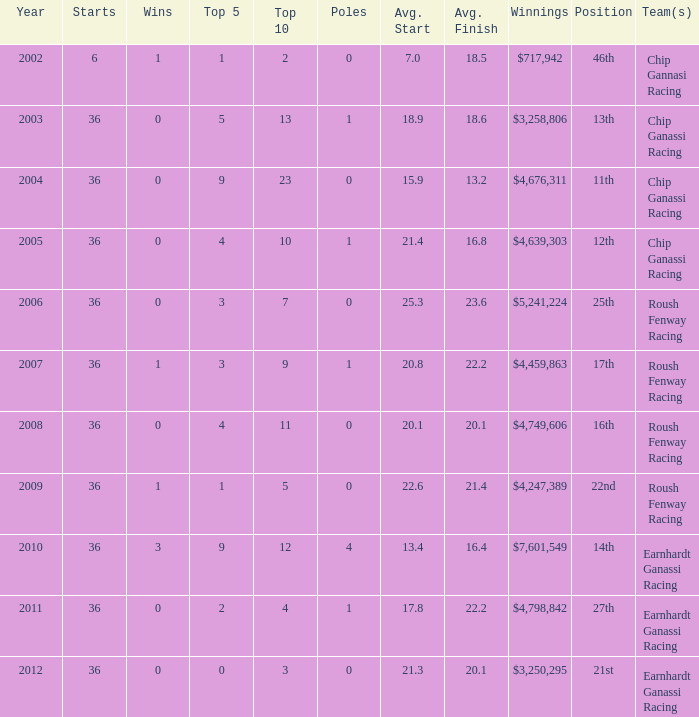Specify the commencement when the standing is 16th. 36.0. 